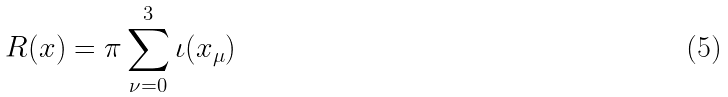Convert formula to latex. <formula><loc_0><loc_0><loc_500><loc_500>R ( x ) = \pi \sum _ { \nu = 0 } ^ { 3 } \iota ( x _ { \mu } )</formula> 